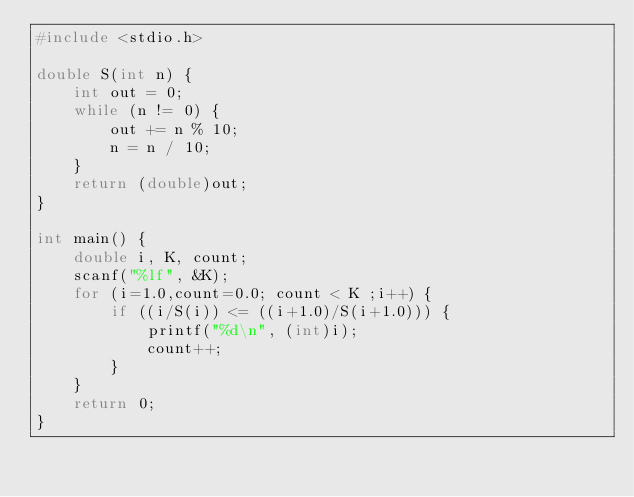Convert code to text. <code><loc_0><loc_0><loc_500><loc_500><_C_>#include <stdio.h>

double S(int n) {
    int out = 0;
    while (n != 0) {
        out += n % 10;
        n = n / 10;
    }
    return (double)out;
}

int main() {
    double i, K, count;
    scanf("%lf", &K);
    for (i=1.0,count=0.0; count < K ;i++) {
        if ((i/S(i)) <= ((i+1.0)/S(i+1.0))) {
            printf("%d\n", (int)i);
            count++;
        }
    }
    return 0;
}</code> 